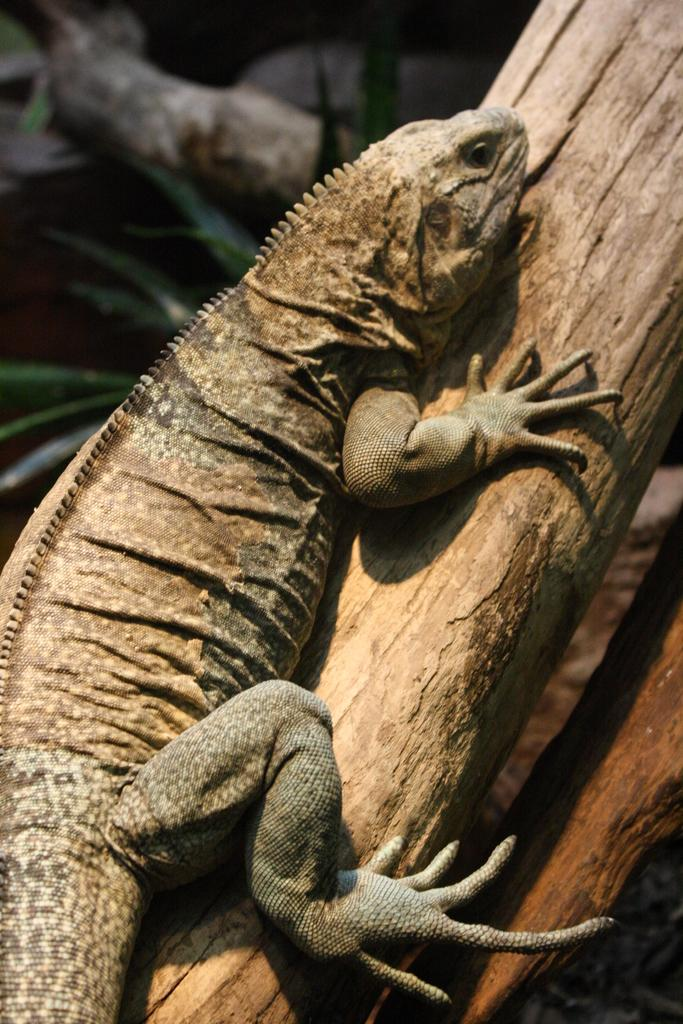What type of animal is in the image? There is a lizard in the image. What is the lizard resting on? The lizard is on a piece of wood. Can you describe the background of the image? The background of the image is blurry. What type of faucet can be seen in the image? There is no faucet present in the image; it features a lizard on a piece of wood with a blurry background. 